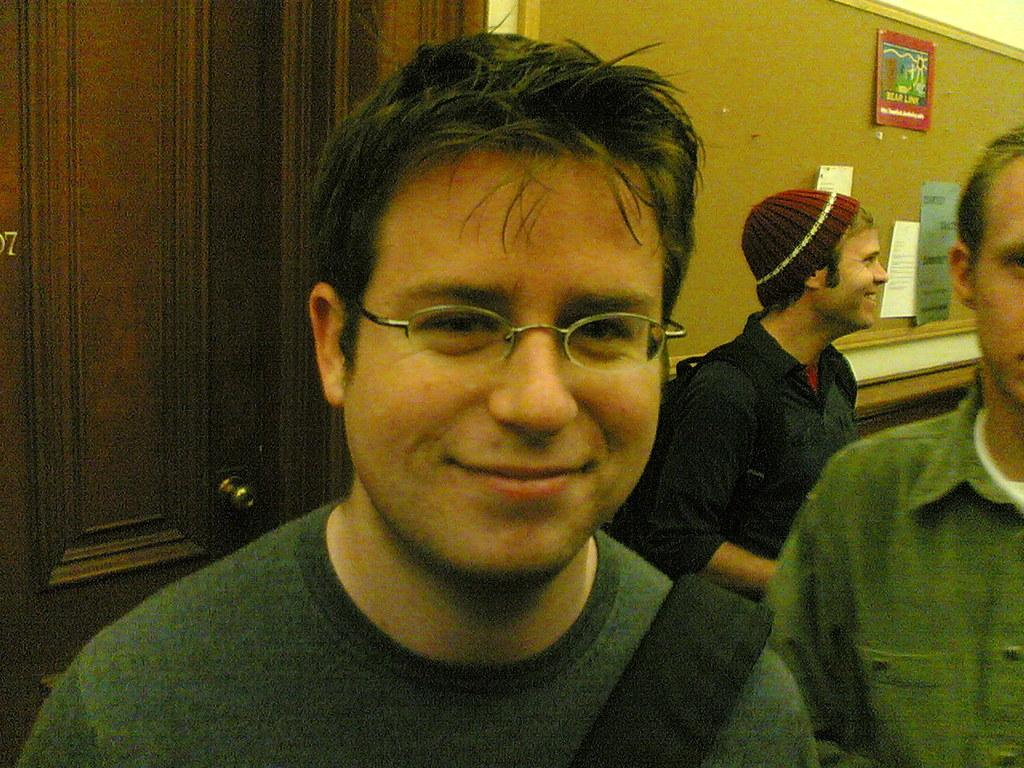What can be seen in the image involving people? There are people standing in the image. What structure is present in the image with information displayed? There is a notice board in the image, with papers pasted on it. Can you describe the background of the image? There is a door visible at the back of the image. Are there any lizards wearing crowns in the image? There are no lizards or crowns present in the image. Is there a church visible in the image? There is no church visible in the image; only a notice board, people, and a door are present. 